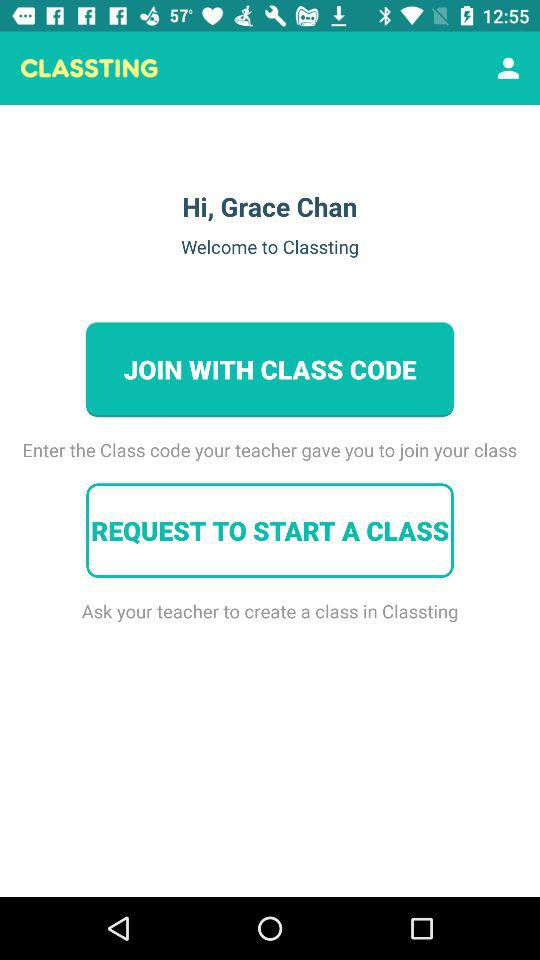What is the application name? The application name is CLASSTING. 